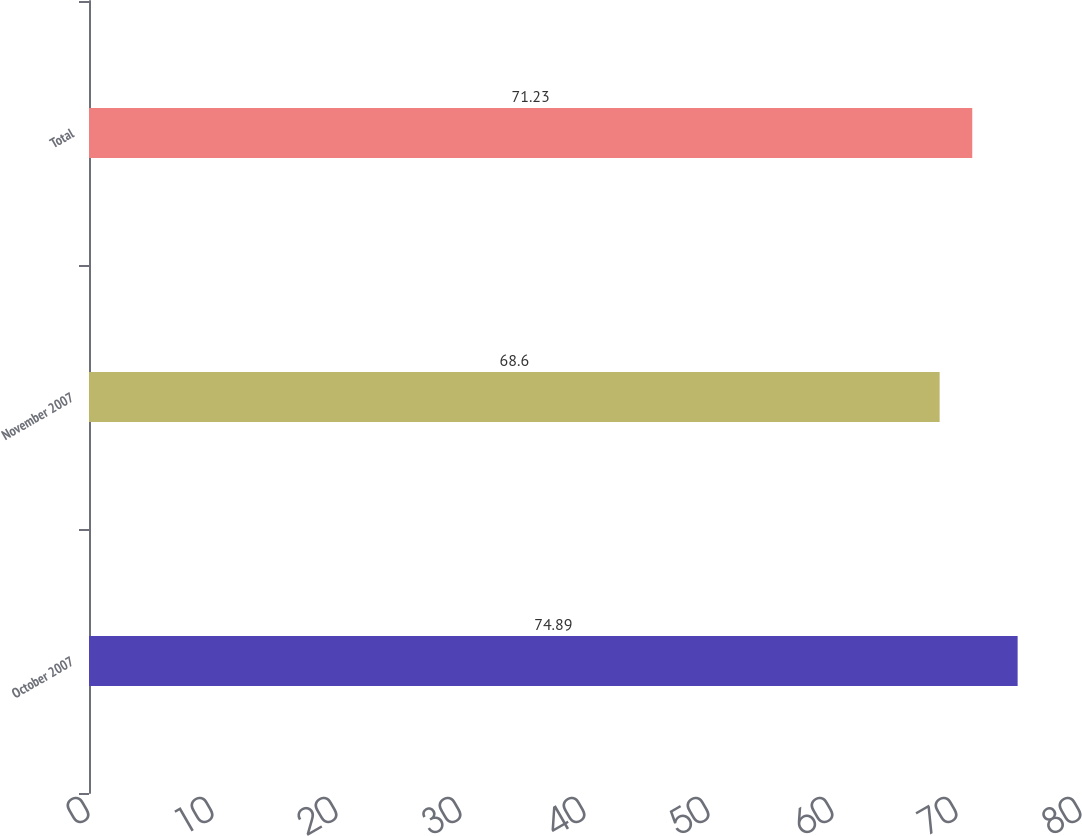Convert chart. <chart><loc_0><loc_0><loc_500><loc_500><bar_chart><fcel>October 2007<fcel>November 2007<fcel>Total<nl><fcel>74.89<fcel>68.6<fcel>71.23<nl></chart> 